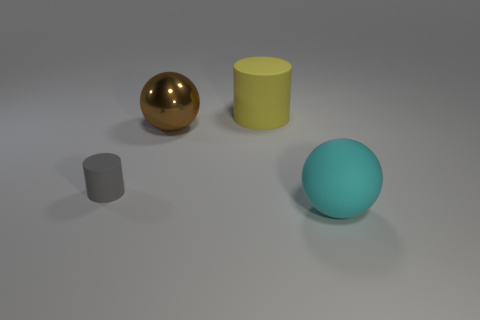Subtract all green balls. Subtract all brown blocks. How many balls are left? 2 Add 4 tiny gray rubber cylinders. How many objects exist? 8 Add 3 big green shiny cubes. How many big green shiny cubes exist? 3 Subtract 0 cyan cylinders. How many objects are left? 4 Subtract all small cyan rubber things. Subtract all brown spheres. How many objects are left? 3 Add 4 yellow rubber things. How many yellow rubber things are left? 5 